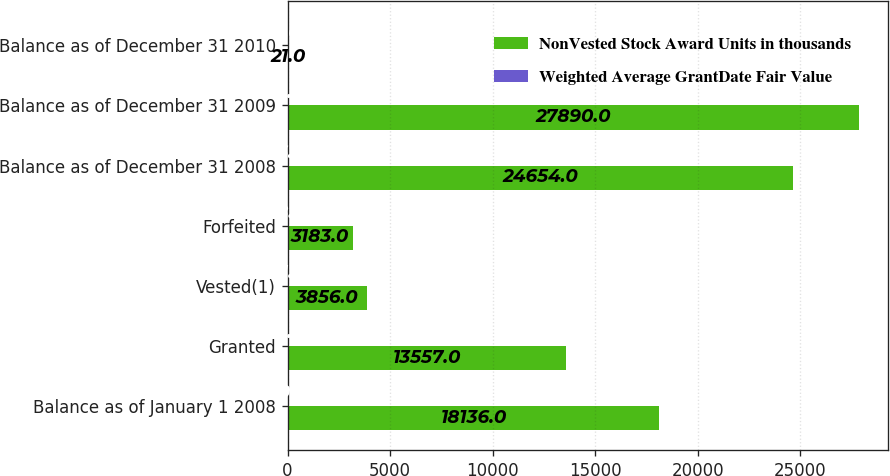Convert chart to OTSL. <chart><loc_0><loc_0><loc_500><loc_500><stacked_bar_chart><ecel><fcel>Balance as of January 1 2008<fcel>Granted<fcel>Vested(1)<fcel>Forfeited<fcel>Balance as of December 31 2008<fcel>Balance as of December 31 2009<fcel>Balance as of December 31 2010<nl><fcel>NonVested Stock Award Units in thousands<fcel>18136<fcel>13557<fcel>3856<fcel>3183<fcel>24654<fcel>27890<fcel>21<nl><fcel>Weighted Average GrantDate Fair Value<fcel>20<fcel>12<fcel>21<fcel>18<fcel>16<fcel>12<fcel>9<nl></chart> 